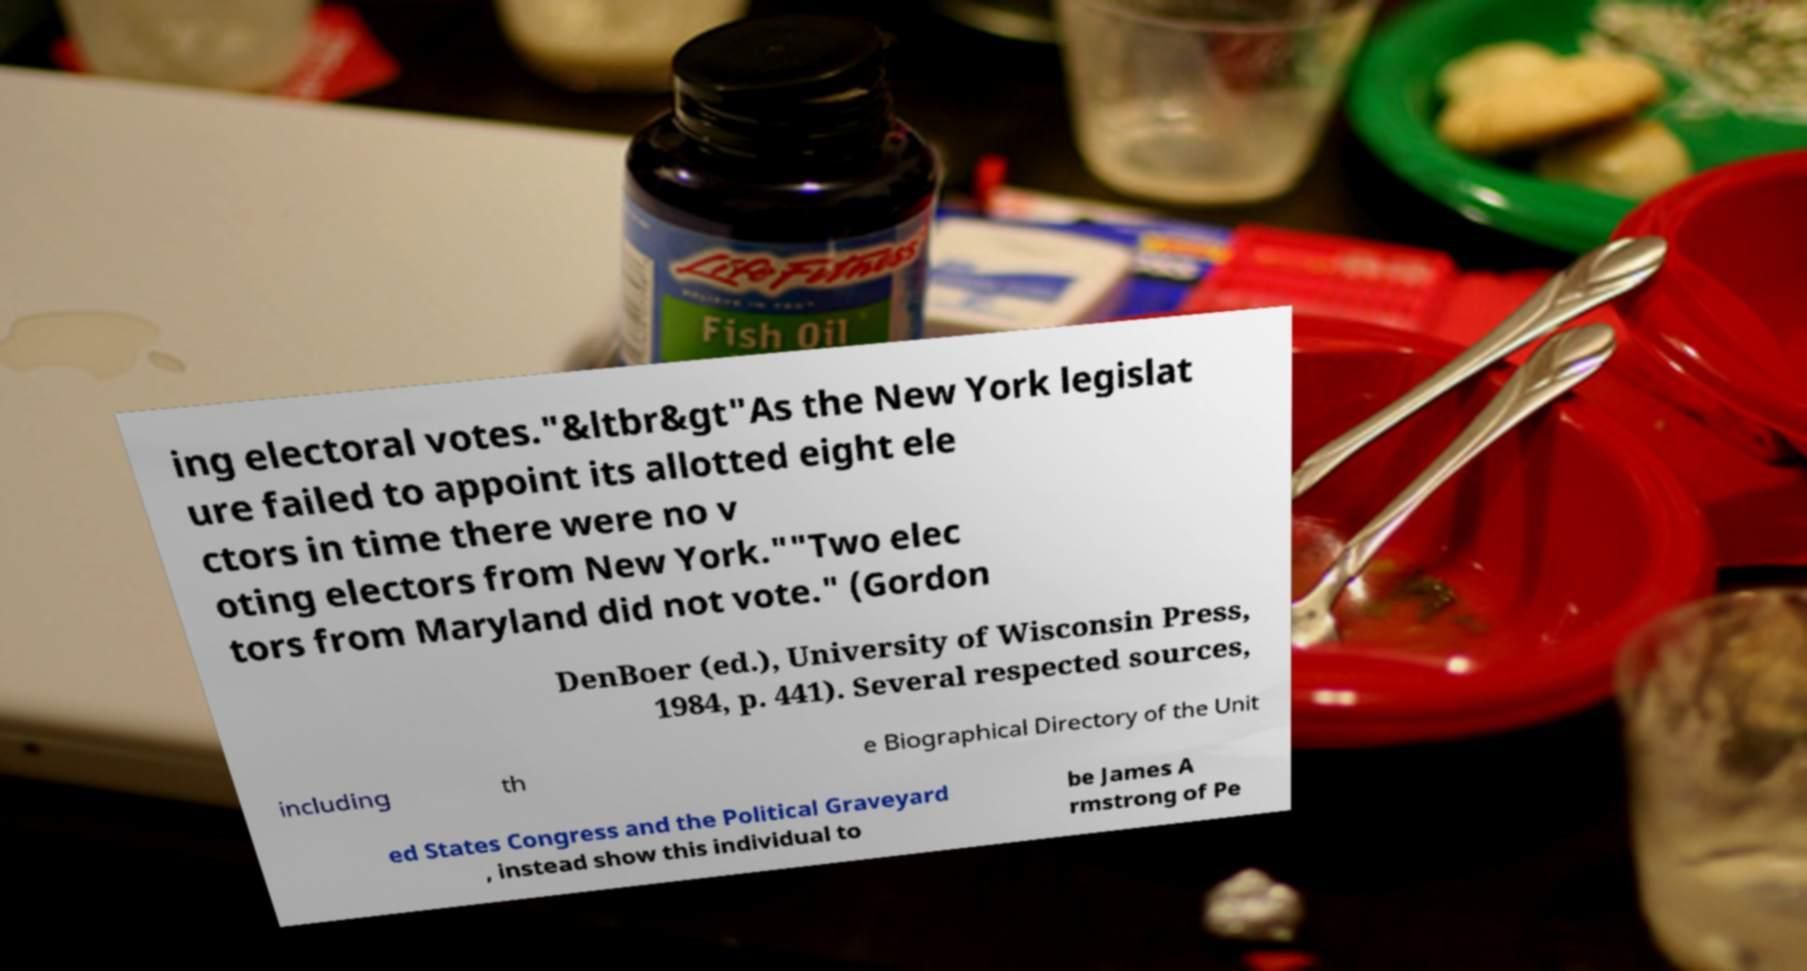For documentation purposes, I need the text within this image transcribed. Could you provide that? ing electoral votes."&ltbr&gt"As the New York legislat ure failed to appoint its allotted eight ele ctors in time there were no v oting electors from New York.""Two elec tors from Maryland did not vote." (Gordon DenBoer (ed.), University of Wisconsin Press, 1984, p. 441). Several respected sources, including th e Biographical Directory of the Unit ed States Congress and the Political Graveyard , instead show this individual to be James A rmstrong of Pe 